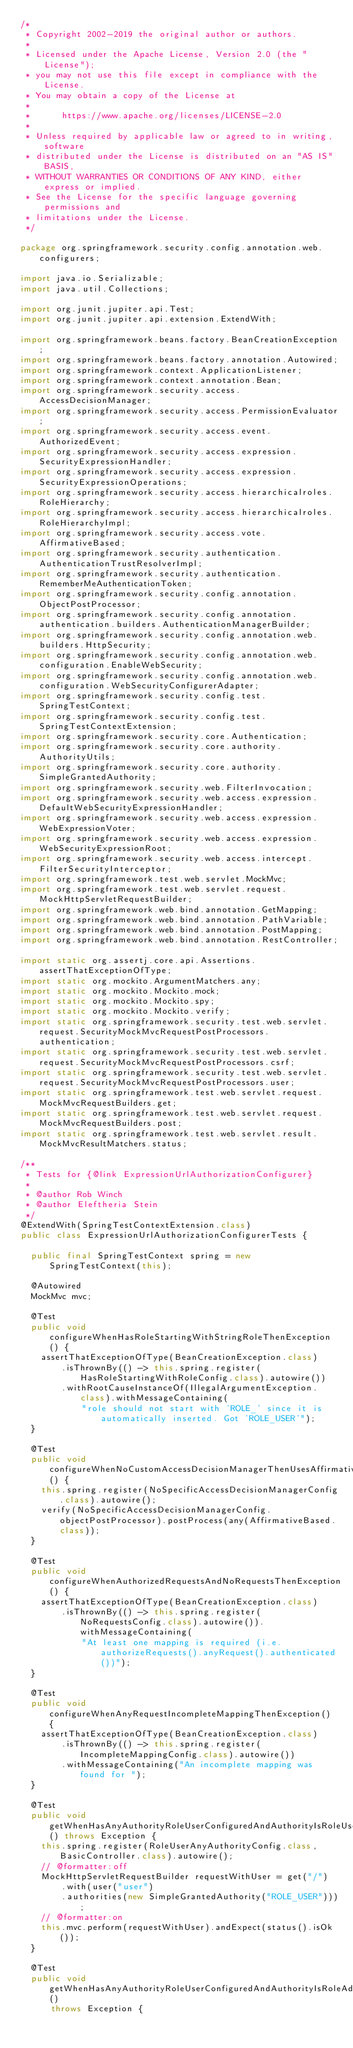Convert code to text. <code><loc_0><loc_0><loc_500><loc_500><_Java_>/*
 * Copyright 2002-2019 the original author or authors.
 *
 * Licensed under the Apache License, Version 2.0 (the "License");
 * you may not use this file except in compliance with the License.
 * You may obtain a copy of the License at
 *
 *      https://www.apache.org/licenses/LICENSE-2.0
 *
 * Unless required by applicable law or agreed to in writing, software
 * distributed under the License is distributed on an "AS IS" BASIS,
 * WITHOUT WARRANTIES OR CONDITIONS OF ANY KIND, either express or implied.
 * See the License for the specific language governing permissions and
 * limitations under the License.
 */

package org.springframework.security.config.annotation.web.configurers;

import java.io.Serializable;
import java.util.Collections;

import org.junit.jupiter.api.Test;
import org.junit.jupiter.api.extension.ExtendWith;

import org.springframework.beans.factory.BeanCreationException;
import org.springframework.beans.factory.annotation.Autowired;
import org.springframework.context.ApplicationListener;
import org.springframework.context.annotation.Bean;
import org.springframework.security.access.AccessDecisionManager;
import org.springframework.security.access.PermissionEvaluator;
import org.springframework.security.access.event.AuthorizedEvent;
import org.springframework.security.access.expression.SecurityExpressionHandler;
import org.springframework.security.access.expression.SecurityExpressionOperations;
import org.springframework.security.access.hierarchicalroles.RoleHierarchy;
import org.springframework.security.access.hierarchicalroles.RoleHierarchyImpl;
import org.springframework.security.access.vote.AffirmativeBased;
import org.springframework.security.authentication.AuthenticationTrustResolverImpl;
import org.springframework.security.authentication.RememberMeAuthenticationToken;
import org.springframework.security.config.annotation.ObjectPostProcessor;
import org.springframework.security.config.annotation.authentication.builders.AuthenticationManagerBuilder;
import org.springframework.security.config.annotation.web.builders.HttpSecurity;
import org.springframework.security.config.annotation.web.configuration.EnableWebSecurity;
import org.springframework.security.config.annotation.web.configuration.WebSecurityConfigurerAdapter;
import org.springframework.security.config.test.SpringTestContext;
import org.springframework.security.config.test.SpringTestContextExtension;
import org.springframework.security.core.Authentication;
import org.springframework.security.core.authority.AuthorityUtils;
import org.springframework.security.core.authority.SimpleGrantedAuthority;
import org.springframework.security.web.FilterInvocation;
import org.springframework.security.web.access.expression.DefaultWebSecurityExpressionHandler;
import org.springframework.security.web.access.expression.WebExpressionVoter;
import org.springframework.security.web.access.expression.WebSecurityExpressionRoot;
import org.springframework.security.web.access.intercept.FilterSecurityInterceptor;
import org.springframework.test.web.servlet.MockMvc;
import org.springframework.test.web.servlet.request.MockHttpServletRequestBuilder;
import org.springframework.web.bind.annotation.GetMapping;
import org.springframework.web.bind.annotation.PathVariable;
import org.springframework.web.bind.annotation.PostMapping;
import org.springframework.web.bind.annotation.RestController;

import static org.assertj.core.api.Assertions.assertThatExceptionOfType;
import static org.mockito.ArgumentMatchers.any;
import static org.mockito.Mockito.mock;
import static org.mockito.Mockito.spy;
import static org.mockito.Mockito.verify;
import static org.springframework.security.test.web.servlet.request.SecurityMockMvcRequestPostProcessors.authentication;
import static org.springframework.security.test.web.servlet.request.SecurityMockMvcRequestPostProcessors.csrf;
import static org.springframework.security.test.web.servlet.request.SecurityMockMvcRequestPostProcessors.user;
import static org.springframework.test.web.servlet.request.MockMvcRequestBuilders.get;
import static org.springframework.test.web.servlet.request.MockMvcRequestBuilders.post;
import static org.springframework.test.web.servlet.result.MockMvcResultMatchers.status;

/**
 * Tests for {@link ExpressionUrlAuthorizationConfigurer}
 *
 * @author Rob Winch
 * @author Eleftheria Stein
 */
@ExtendWith(SpringTestContextExtension.class)
public class ExpressionUrlAuthorizationConfigurerTests {

	public final SpringTestContext spring = new SpringTestContext(this);

	@Autowired
	MockMvc mvc;

	@Test
	public void configureWhenHasRoleStartingWithStringRoleThenException() {
		assertThatExceptionOfType(BeanCreationException.class)
				.isThrownBy(() -> this.spring.register(HasRoleStartingWithRoleConfig.class).autowire())
				.withRootCauseInstanceOf(IllegalArgumentException.class).withMessageContaining(
						"role should not start with 'ROLE_' since it is automatically inserted. Got 'ROLE_USER'");
	}

	@Test
	public void configureWhenNoCustomAccessDecisionManagerThenUsesAffirmativeBased() {
		this.spring.register(NoSpecificAccessDecisionManagerConfig.class).autowire();
		verify(NoSpecificAccessDecisionManagerConfig.objectPostProcessor).postProcess(any(AffirmativeBased.class));
	}

	@Test
	public void configureWhenAuthorizedRequestsAndNoRequestsThenException() {
		assertThatExceptionOfType(BeanCreationException.class)
				.isThrownBy(() -> this.spring.register(NoRequestsConfig.class).autowire()).withMessageContaining(
						"At least one mapping is required (i.e. authorizeRequests().anyRequest().authenticated())");
	}

	@Test
	public void configureWhenAnyRequestIncompleteMappingThenException() {
		assertThatExceptionOfType(BeanCreationException.class)
				.isThrownBy(() -> this.spring.register(IncompleteMappingConfig.class).autowire())
				.withMessageContaining("An incomplete mapping was found for ");
	}

	@Test
	public void getWhenHasAnyAuthorityRoleUserConfiguredAndAuthorityIsRoleUserThenRespondsWithOk() throws Exception {
		this.spring.register(RoleUserAnyAuthorityConfig.class, BasicController.class).autowire();
		// @formatter:off
		MockHttpServletRequestBuilder requestWithUser = get("/")
				.with(user("user")
				.authorities(new SimpleGrantedAuthority("ROLE_USER")));
		// @formatter:on
		this.mvc.perform(requestWithUser).andExpect(status().isOk());
	}

	@Test
	public void getWhenHasAnyAuthorityRoleUserConfiguredAndAuthorityIsRoleAdminThenRespondsWithForbidden()
			throws Exception {</code> 